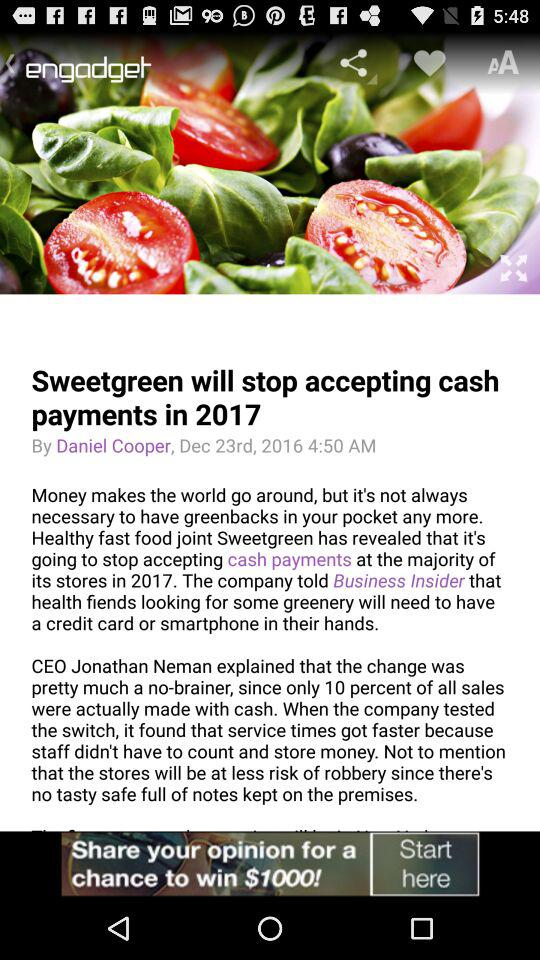Who is the CEO of the company? The CEO of the company is Jonathan Nemen. 